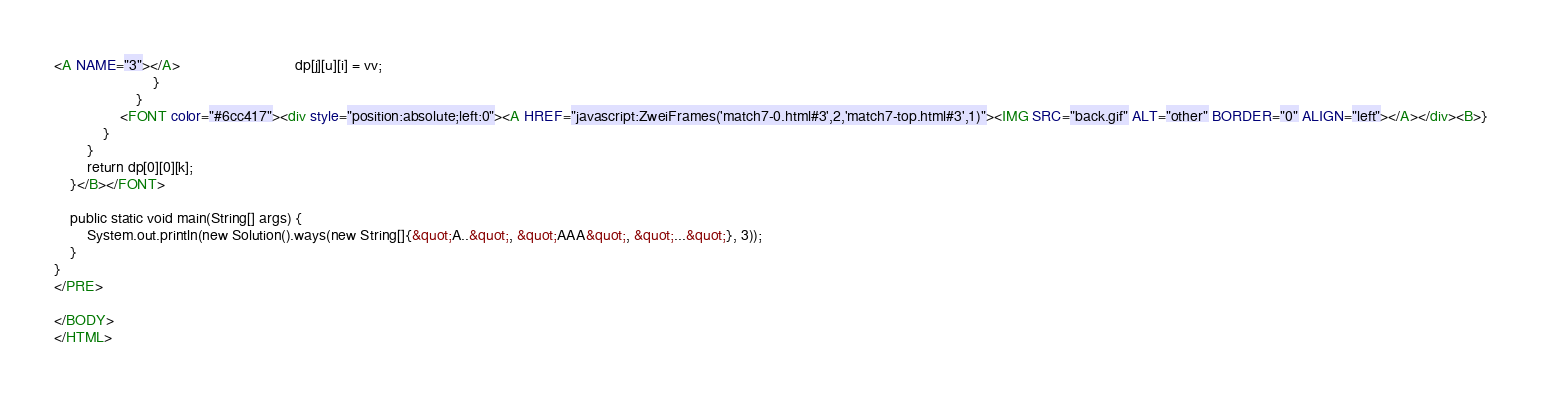Convert code to text. <code><loc_0><loc_0><loc_500><loc_500><_HTML_><A NAME="3"></A>                            dp[j][u][i] = vv;
                        }
                    }
                <FONT color="#6cc417"><div style="position:absolute;left:0"><A HREF="javascript:ZweiFrames('match7-0.html#3',2,'match7-top.html#3',1)"><IMG SRC="back.gif" ALT="other" BORDER="0" ALIGN="left"></A></div><B>}
            }
        }
        return dp[0][0][k];
    }</B></FONT>

    public static void main(String[] args) {
        System.out.println(new Solution().ways(new String[]{&quot;A..&quot;, &quot;AAA&quot;, &quot;...&quot;}, 3));
    }
}
</PRE>

</BODY>
</HTML>
</code> 